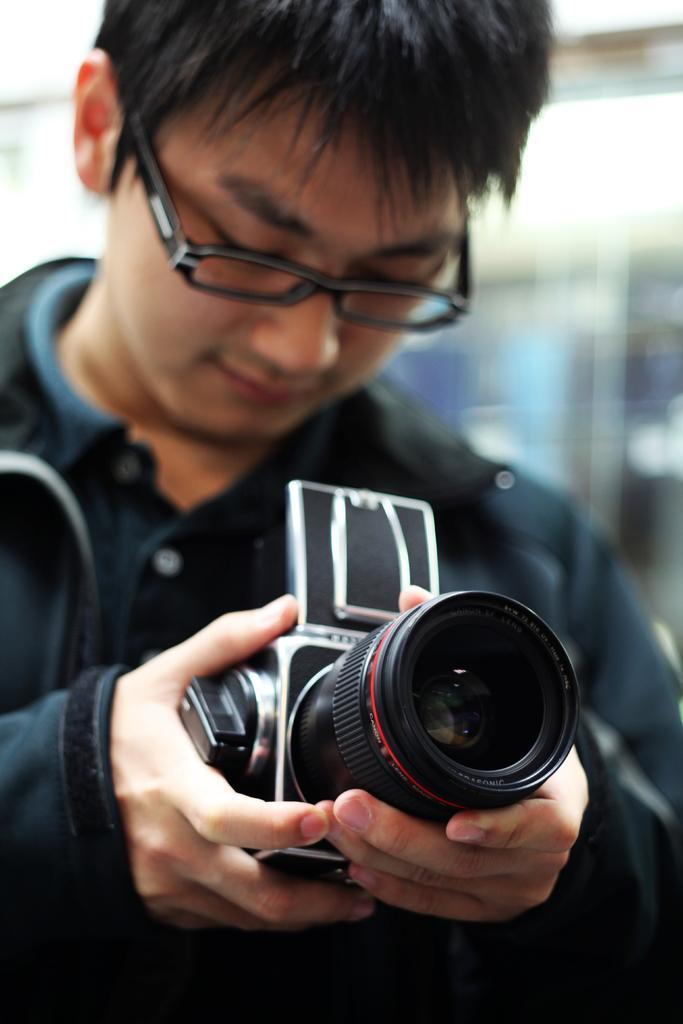Describe this image in one or two sentences. Here a man is holding camera in his hand. 